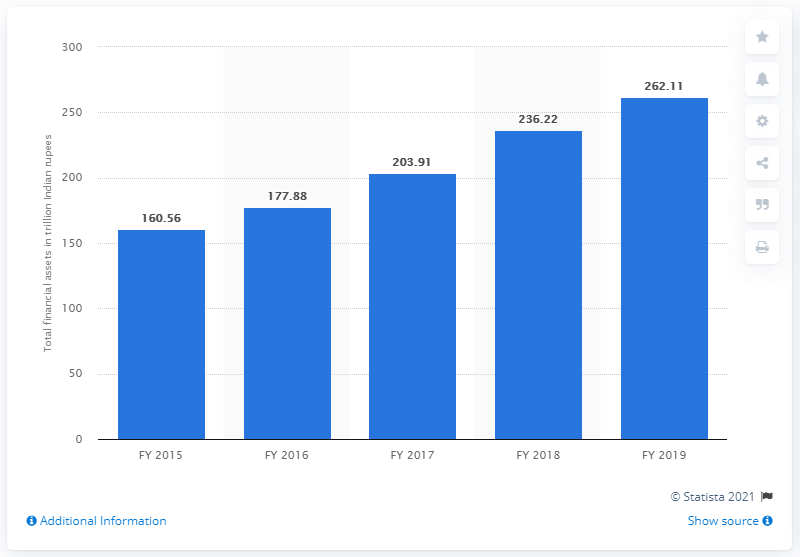Draw attention to some important aspects in this diagram. In the previous financial year, the amount of financial assets held by individuals was 236.22 rupees. In 2019, there were 262.11 Indian rupees held by individuals, according to the data. 